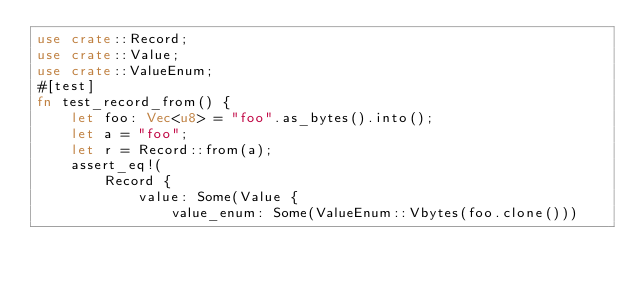Convert code to text. <code><loc_0><loc_0><loc_500><loc_500><_Rust_>use crate::Record;
use crate::Value;
use crate::ValueEnum;
#[test]
fn test_record_from() {
    let foo: Vec<u8> = "foo".as_bytes().into();
    let a = "foo";
    let r = Record::from(a);
    assert_eq!(
        Record {
            value: Some(Value {
                value_enum: Some(ValueEnum::Vbytes(foo.clone()))</code> 